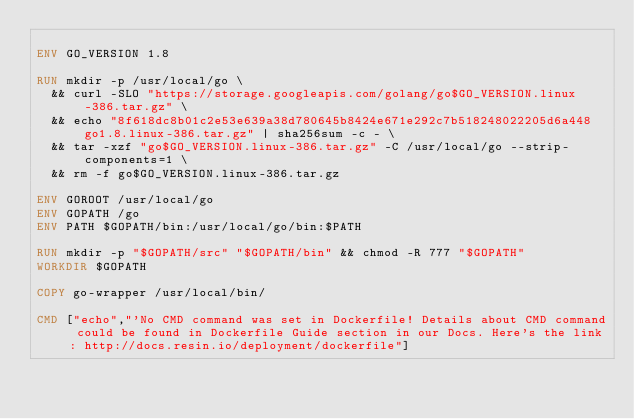<code> <loc_0><loc_0><loc_500><loc_500><_Dockerfile_>
ENV GO_VERSION 1.8

RUN mkdir -p /usr/local/go \
	&& curl -SLO "https://storage.googleapis.com/golang/go$GO_VERSION.linux-386.tar.gz" \
	&& echo "8f618dc8b01c2e53e639a38d780645b8424e671e292c7b518248022205d6a448  go1.8.linux-386.tar.gz" | sha256sum -c - \
	&& tar -xzf "go$GO_VERSION.linux-386.tar.gz" -C /usr/local/go --strip-components=1 \
	&& rm -f go$GO_VERSION.linux-386.tar.gz

ENV GOROOT /usr/local/go
ENV GOPATH /go
ENV PATH $GOPATH/bin:/usr/local/go/bin:$PATH

RUN mkdir -p "$GOPATH/src" "$GOPATH/bin" && chmod -R 777 "$GOPATH"
WORKDIR $GOPATH

COPY go-wrapper /usr/local/bin/

CMD ["echo","'No CMD command was set in Dockerfile! Details about CMD command could be found in Dockerfile Guide section in our Docs. Here's the link: http://docs.resin.io/deployment/dockerfile"]
</code> 